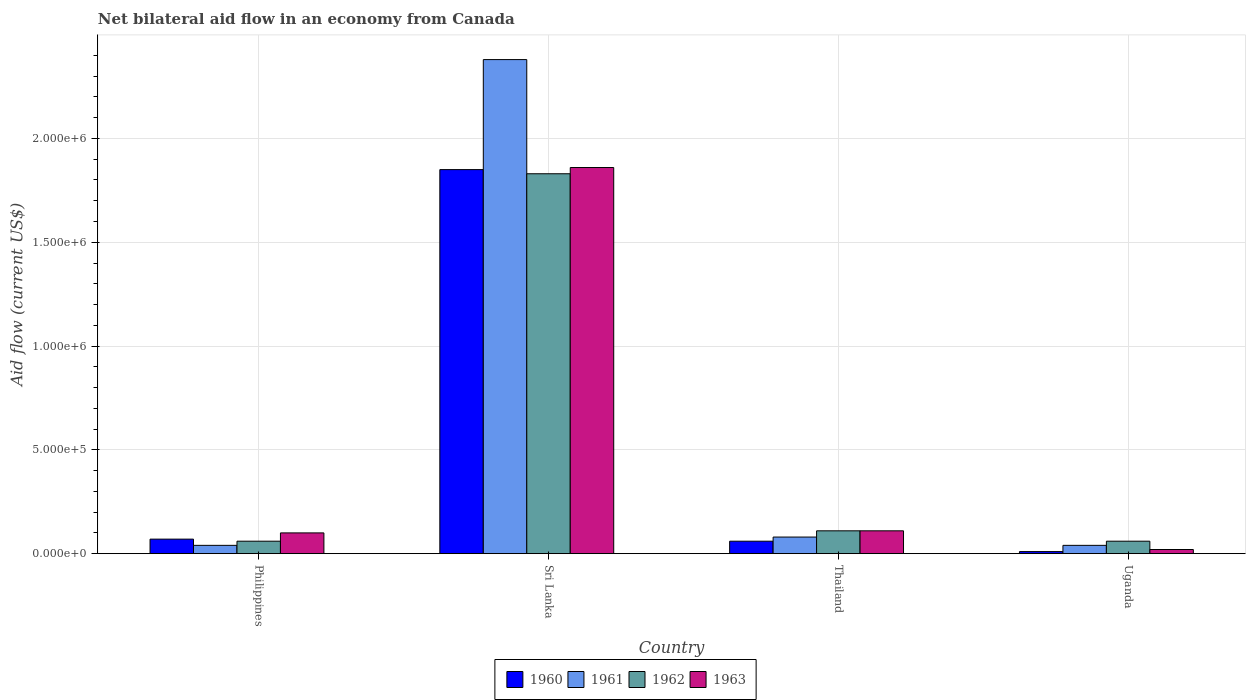Are the number of bars per tick equal to the number of legend labels?
Provide a succinct answer. Yes. Are the number of bars on each tick of the X-axis equal?
Keep it short and to the point. Yes. How many bars are there on the 1st tick from the right?
Keep it short and to the point. 4. What is the label of the 4th group of bars from the left?
Ensure brevity in your answer.  Uganda. In how many cases, is the number of bars for a given country not equal to the number of legend labels?
Offer a very short reply. 0. What is the net bilateral aid flow in 1962 in Uganda?
Your answer should be very brief. 6.00e+04. Across all countries, what is the maximum net bilateral aid flow in 1962?
Give a very brief answer. 1.83e+06. Across all countries, what is the minimum net bilateral aid flow in 1960?
Offer a terse response. 10000. In which country was the net bilateral aid flow in 1962 maximum?
Give a very brief answer. Sri Lanka. In which country was the net bilateral aid flow in 1960 minimum?
Provide a short and direct response. Uganda. What is the total net bilateral aid flow in 1960 in the graph?
Your answer should be compact. 1.99e+06. What is the difference between the net bilateral aid flow in 1962 in Philippines and that in Uganda?
Provide a short and direct response. 0. What is the average net bilateral aid flow in 1962 per country?
Provide a short and direct response. 5.15e+05. What is the difference between the net bilateral aid flow of/in 1963 and net bilateral aid flow of/in 1960 in Thailand?
Ensure brevity in your answer.  5.00e+04. In how many countries, is the net bilateral aid flow in 1960 greater than 2300000 US$?
Give a very brief answer. 0. What is the ratio of the net bilateral aid flow in 1962 in Philippines to that in Sri Lanka?
Your response must be concise. 0.03. Is the net bilateral aid flow in 1963 in Philippines less than that in Sri Lanka?
Your response must be concise. Yes. Is the difference between the net bilateral aid flow in 1963 in Sri Lanka and Uganda greater than the difference between the net bilateral aid flow in 1960 in Sri Lanka and Uganda?
Make the answer very short. No. What is the difference between the highest and the second highest net bilateral aid flow in 1962?
Provide a succinct answer. 1.77e+06. What is the difference between the highest and the lowest net bilateral aid flow in 1963?
Offer a very short reply. 1.84e+06. How many countries are there in the graph?
Provide a succinct answer. 4. Does the graph contain any zero values?
Offer a terse response. No. Where does the legend appear in the graph?
Provide a short and direct response. Bottom center. What is the title of the graph?
Offer a terse response. Net bilateral aid flow in an economy from Canada. Does "1980" appear as one of the legend labels in the graph?
Your answer should be very brief. No. What is the Aid flow (current US$) of 1961 in Philippines?
Offer a very short reply. 4.00e+04. What is the Aid flow (current US$) of 1963 in Philippines?
Ensure brevity in your answer.  1.00e+05. What is the Aid flow (current US$) of 1960 in Sri Lanka?
Your answer should be very brief. 1.85e+06. What is the Aid flow (current US$) of 1961 in Sri Lanka?
Provide a succinct answer. 2.38e+06. What is the Aid flow (current US$) in 1962 in Sri Lanka?
Keep it short and to the point. 1.83e+06. What is the Aid flow (current US$) in 1963 in Sri Lanka?
Provide a succinct answer. 1.86e+06. What is the Aid flow (current US$) in 1960 in Thailand?
Your answer should be very brief. 6.00e+04. What is the Aid flow (current US$) in 1961 in Thailand?
Provide a short and direct response. 8.00e+04. What is the Aid flow (current US$) in 1962 in Thailand?
Keep it short and to the point. 1.10e+05. What is the Aid flow (current US$) in 1961 in Uganda?
Your answer should be compact. 4.00e+04. Across all countries, what is the maximum Aid flow (current US$) in 1960?
Your answer should be compact. 1.85e+06. Across all countries, what is the maximum Aid flow (current US$) in 1961?
Your answer should be very brief. 2.38e+06. Across all countries, what is the maximum Aid flow (current US$) in 1962?
Make the answer very short. 1.83e+06. Across all countries, what is the maximum Aid flow (current US$) in 1963?
Your answer should be very brief. 1.86e+06. Across all countries, what is the minimum Aid flow (current US$) of 1961?
Your answer should be very brief. 4.00e+04. Across all countries, what is the minimum Aid flow (current US$) of 1962?
Make the answer very short. 6.00e+04. What is the total Aid flow (current US$) of 1960 in the graph?
Keep it short and to the point. 1.99e+06. What is the total Aid flow (current US$) of 1961 in the graph?
Keep it short and to the point. 2.54e+06. What is the total Aid flow (current US$) in 1962 in the graph?
Offer a very short reply. 2.06e+06. What is the total Aid flow (current US$) of 1963 in the graph?
Your answer should be very brief. 2.09e+06. What is the difference between the Aid flow (current US$) of 1960 in Philippines and that in Sri Lanka?
Your answer should be very brief. -1.78e+06. What is the difference between the Aid flow (current US$) in 1961 in Philippines and that in Sri Lanka?
Your answer should be very brief. -2.34e+06. What is the difference between the Aid flow (current US$) in 1962 in Philippines and that in Sri Lanka?
Give a very brief answer. -1.77e+06. What is the difference between the Aid flow (current US$) in 1963 in Philippines and that in Sri Lanka?
Offer a terse response. -1.76e+06. What is the difference between the Aid flow (current US$) in 1962 in Philippines and that in Uganda?
Provide a succinct answer. 0. What is the difference between the Aid flow (current US$) of 1963 in Philippines and that in Uganda?
Your answer should be very brief. 8.00e+04. What is the difference between the Aid flow (current US$) of 1960 in Sri Lanka and that in Thailand?
Provide a short and direct response. 1.79e+06. What is the difference between the Aid flow (current US$) in 1961 in Sri Lanka and that in Thailand?
Provide a succinct answer. 2.30e+06. What is the difference between the Aid flow (current US$) of 1962 in Sri Lanka and that in Thailand?
Your answer should be very brief. 1.72e+06. What is the difference between the Aid flow (current US$) in 1963 in Sri Lanka and that in Thailand?
Offer a terse response. 1.75e+06. What is the difference between the Aid flow (current US$) of 1960 in Sri Lanka and that in Uganda?
Offer a very short reply. 1.84e+06. What is the difference between the Aid flow (current US$) of 1961 in Sri Lanka and that in Uganda?
Ensure brevity in your answer.  2.34e+06. What is the difference between the Aid flow (current US$) in 1962 in Sri Lanka and that in Uganda?
Make the answer very short. 1.77e+06. What is the difference between the Aid flow (current US$) of 1963 in Sri Lanka and that in Uganda?
Provide a succinct answer. 1.84e+06. What is the difference between the Aid flow (current US$) in 1960 in Philippines and the Aid flow (current US$) in 1961 in Sri Lanka?
Offer a very short reply. -2.31e+06. What is the difference between the Aid flow (current US$) of 1960 in Philippines and the Aid flow (current US$) of 1962 in Sri Lanka?
Provide a short and direct response. -1.76e+06. What is the difference between the Aid flow (current US$) in 1960 in Philippines and the Aid flow (current US$) in 1963 in Sri Lanka?
Keep it short and to the point. -1.79e+06. What is the difference between the Aid flow (current US$) of 1961 in Philippines and the Aid flow (current US$) of 1962 in Sri Lanka?
Your answer should be very brief. -1.79e+06. What is the difference between the Aid flow (current US$) in 1961 in Philippines and the Aid flow (current US$) in 1963 in Sri Lanka?
Offer a terse response. -1.82e+06. What is the difference between the Aid flow (current US$) of 1962 in Philippines and the Aid flow (current US$) of 1963 in Sri Lanka?
Offer a very short reply. -1.80e+06. What is the difference between the Aid flow (current US$) in 1960 in Philippines and the Aid flow (current US$) in 1961 in Thailand?
Offer a very short reply. -10000. What is the difference between the Aid flow (current US$) in 1960 in Philippines and the Aid flow (current US$) in 1962 in Thailand?
Offer a very short reply. -4.00e+04. What is the difference between the Aid flow (current US$) of 1960 in Philippines and the Aid flow (current US$) of 1963 in Thailand?
Provide a short and direct response. -4.00e+04. What is the difference between the Aid flow (current US$) in 1961 in Philippines and the Aid flow (current US$) in 1962 in Thailand?
Your answer should be compact. -7.00e+04. What is the difference between the Aid flow (current US$) in 1961 in Philippines and the Aid flow (current US$) in 1963 in Thailand?
Give a very brief answer. -7.00e+04. What is the difference between the Aid flow (current US$) in 1962 in Philippines and the Aid flow (current US$) in 1963 in Thailand?
Your response must be concise. -5.00e+04. What is the difference between the Aid flow (current US$) in 1960 in Philippines and the Aid flow (current US$) in 1961 in Uganda?
Ensure brevity in your answer.  3.00e+04. What is the difference between the Aid flow (current US$) in 1961 in Philippines and the Aid flow (current US$) in 1963 in Uganda?
Offer a very short reply. 2.00e+04. What is the difference between the Aid flow (current US$) of 1962 in Philippines and the Aid flow (current US$) of 1963 in Uganda?
Your response must be concise. 4.00e+04. What is the difference between the Aid flow (current US$) of 1960 in Sri Lanka and the Aid flow (current US$) of 1961 in Thailand?
Your answer should be very brief. 1.77e+06. What is the difference between the Aid flow (current US$) in 1960 in Sri Lanka and the Aid flow (current US$) in 1962 in Thailand?
Your response must be concise. 1.74e+06. What is the difference between the Aid flow (current US$) of 1960 in Sri Lanka and the Aid flow (current US$) of 1963 in Thailand?
Give a very brief answer. 1.74e+06. What is the difference between the Aid flow (current US$) of 1961 in Sri Lanka and the Aid flow (current US$) of 1962 in Thailand?
Provide a succinct answer. 2.27e+06. What is the difference between the Aid flow (current US$) in 1961 in Sri Lanka and the Aid flow (current US$) in 1963 in Thailand?
Your answer should be very brief. 2.27e+06. What is the difference between the Aid flow (current US$) of 1962 in Sri Lanka and the Aid flow (current US$) of 1963 in Thailand?
Your answer should be very brief. 1.72e+06. What is the difference between the Aid flow (current US$) of 1960 in Sri Lanka and the Aid flow (current US$) of 1961 in Uganda?
Ensure brevity in your answer.  1.81e+06. What is the difference between the Aid flow (current US$) of 1960 in Sri Lanka and the Aid flow (current US$) of 1962 in Uganda?
Provide a short and direct response. 1.79e+06. What is the difference between the Aid flow (current US$) in 1960 in Sri Lanka and the Aid flow (current US$) in 1963 in Uganda?
Offer a very short reply. 1.83e+06. What is the difference between the Aid flow (current US$) in 1961 in Sri Lanka and the Aid flow (current US$) in 1962 in Uganda?
Provide a succinct answer. 2.32e+06. What is the difference between the Aid flow (current US$) of 1961 in Sri Lanka and the Aid flow (current US$) of 1963 in Uganda?
Make the answer very short. 2.36e+06. What is the difference between the Aid flow (current US$) in 1962 in Sri Lanka and the Aid flow (current US$) in 1963 in Uganda?
Offer a terse response. 1.81e+06. What is the difference between the Aid flow (current US$) in 1960 in Thailand and the Aid flow (current US$) in 1962 in Uganda?
Your answer should be very brief. 0. What is the difference between the Aid flow (current US$) of 1960 in Thailand and the Aid flow (current US$) of 1963 in Uganda?
Offer a terse response. 4.00e+04. What is the difference between the Aid flow (current US$) in 1961 in Thailand and the Aid flow (current US$) in 1962 in Uganda?
Your response must be concise. 2.00e+04. What is the difference between the Aid flow (current US$) of 1961 in Thailand and the Aid flow (current US$) of 1963 in Uganda?
Give a very brief answer. 6.00e+04. What is the average Aid flow (current US$) of 1960 per country?
Make the answer very short. 4.98e+05. What is the average Aid flow (current US$) of 1961 per country?
Make the answer very short. 6.35e+05. What is the average Aid flow (current US$) in 1962 per country?
Provide a short and direct response. 5.15e+05. What is the average Aid flow (current US$) of 1963 per country?
Your response must be concise. 5.22e+05. What is the difference between the Aid flow (current US$) in 1960 and Aid flow (current US$) in 1962 in Philippines?
Give a very brief answer. 10000. What is the difference between the Aid flow (current US$) of 1961 and Aid flow (current US$) of 1962 in Philippines?
Make the answer very short. -2.00e+04. What is the difference between the Aid flow (current US$) in 1960 and Aid flow (current US$) in 1961 in Sri Lanka?
Provide a short and direct response. -5.30e+05. What is the difference between the Aid flow (current US$) in 1960 and Aid flow (current US$) in 1962 in Sri Lanka?
Your answer should be compact. 2.00e+04. What is the difference between the Aid flow (current US$) of 1960 and Aid flow (current US$) of 1963 in Sri Lanka?
Keep it short and to the point. -10000. What is the difference between the Aid flow (current US$) in 1961 and Aid flow (current US$) in 1962 in Sri Lanka?
Your answer should be compact. 5.50e+05. What is the difference between the Aid flow (current US$) of 1961 and Aid flow (current US$) of 1963 in Sri Lanka?
Keep it short and to the point. 5.20e+05. What is the difference between the Aid flow (current US$) of 1962 and Aid flow (current US$) of 1963 in Sri Lanka?
Ensure brevity in your answer.  -3.00e+04. What is the difference between the Aid flow (current US$) in 1960 and Aid flow (current US$) in 1963 in Thailand?
Your answer should be compact. -5.00e+04. What is the difference between the Aid flow (current US$) of 1961 and Aid flow (current US$) of 1962 in Thailand?
Your answer should be compact. -3.00e+04. What is the difference between the Aid flow (current US$) in 1962 and Aid flow (current US$) in 1963 in Thailand?
Offer a very short reply. 0. What is the ratio of the Aid flow (current US$) of 1960 in Philippines to that in Sri Lanka?
Your answer should be compact. 0.04. What is the ratio of the Aid flow (current US$) in 1961 in Philippines to that in Sri Lanka?
Make the answer very short. 0.02. What is the ratio of the Aid flow (current US$) in 1962 in Philippines to that in Sri Lanka?
Offer a very short reply. 0.03. What is the ratio of the Aid flow (current US$) in 1963 in Philippines to that in Sri Lanka?
Provide a succinct answer. 0.05. What is the ratio of the Aid flow (current US$) in 1961 in Philippines to that in Thailand?
Offer a very short reply. 0.5. What is the ratio of the Aid flow (current US$) in 1962 in Philippines to that in Thailand?
Make the answer very short. 0.55. What is the ratio of the Aid flow (current US$) of 1960 in Sri Lanka to that in Thailand?
Keep it short and to the point. 30.83. What is the ratio of the Aid flow (current US$) in 1961 in Sri Lanka to that in Thailand?
Give a very brief answer. 29.75. What is the ratio of the Aid flow (current US$) in 1962 in Sri Lanka to that in Thailand?
Give a very brief answer. 16.64. What is the ratio of the Aid flow (current US$) of 1963 in Sri Lanka to that in Thailand?
Make the answer very short. 16.91. What is the ratio of the Aid flow (current US$) in 1960 in Sri Lanka to that in Uganda?
Provide a short and direct response. 185. What is the ratio of the Aid flow (current US$) in 1961 in Sri Lanka to that in Uganda?
Give a very brief answer. 59.5. What is the ratio of the Aid flow (current US$) of 1962 in Sri Lanka to that in Uganda?
Give a very brief answer. 30.5. What is the ratio of the Aid flow (current US$) of 1963 in Sri Lanka to that in Uganda?
Give a very brief answer. 93. What is the ratio of the Aid flow (current US$) of 1960 in Thailand to that in Uganda?
Your answer should be compact. 6. What is the ratio of the Aid flow (current US$) in 1961 in Thailand to that in Uganda?
Ensure brevity in your answer.  2. What is the ratio of the Aid flow (current US$) of 1962 in Thailand to that in Uganda?
Offer a very short reply. 1.83. What is the ratio of the Aid flow (current US$) in 1963 in Thailand to that in Uganda?
Offer a terse response. 5.5. What is the difference between the highest and the second highest Aid flow (current US$) of 1960?
Your response must be concise. 1.78e+06. What is the difference between the highest and the second highest Aid flow (current US$) in 1961?
Offer a terse response. 2.30e+06. What is the difference between the highest and the second highest Aid flow (current US$) in 1962?
Keep it short and to the point. 1.72e+06. What is the difference between the highest and the second highest Aid flow (current US$) of 1963?
Provide a succinct answer. 1.75e+06. What is the difference between the highest and the lowest Aid flow (current US$) in 1960?
Your answer should be very brief. 1.84e+06. What is the difference between the highest and the lowest Aid flow (current US$) in 1961?
Give a very brief answer. 2.34e+06. What is the difference between the highest and the lowest Aid flow (current US$) of 1962?
Your answer should be compact. 1.77e+06. What is the difference between the highest and the lowest Aid flow (current US$) of 1963?
Your response must be concise. 1.84e+06. 